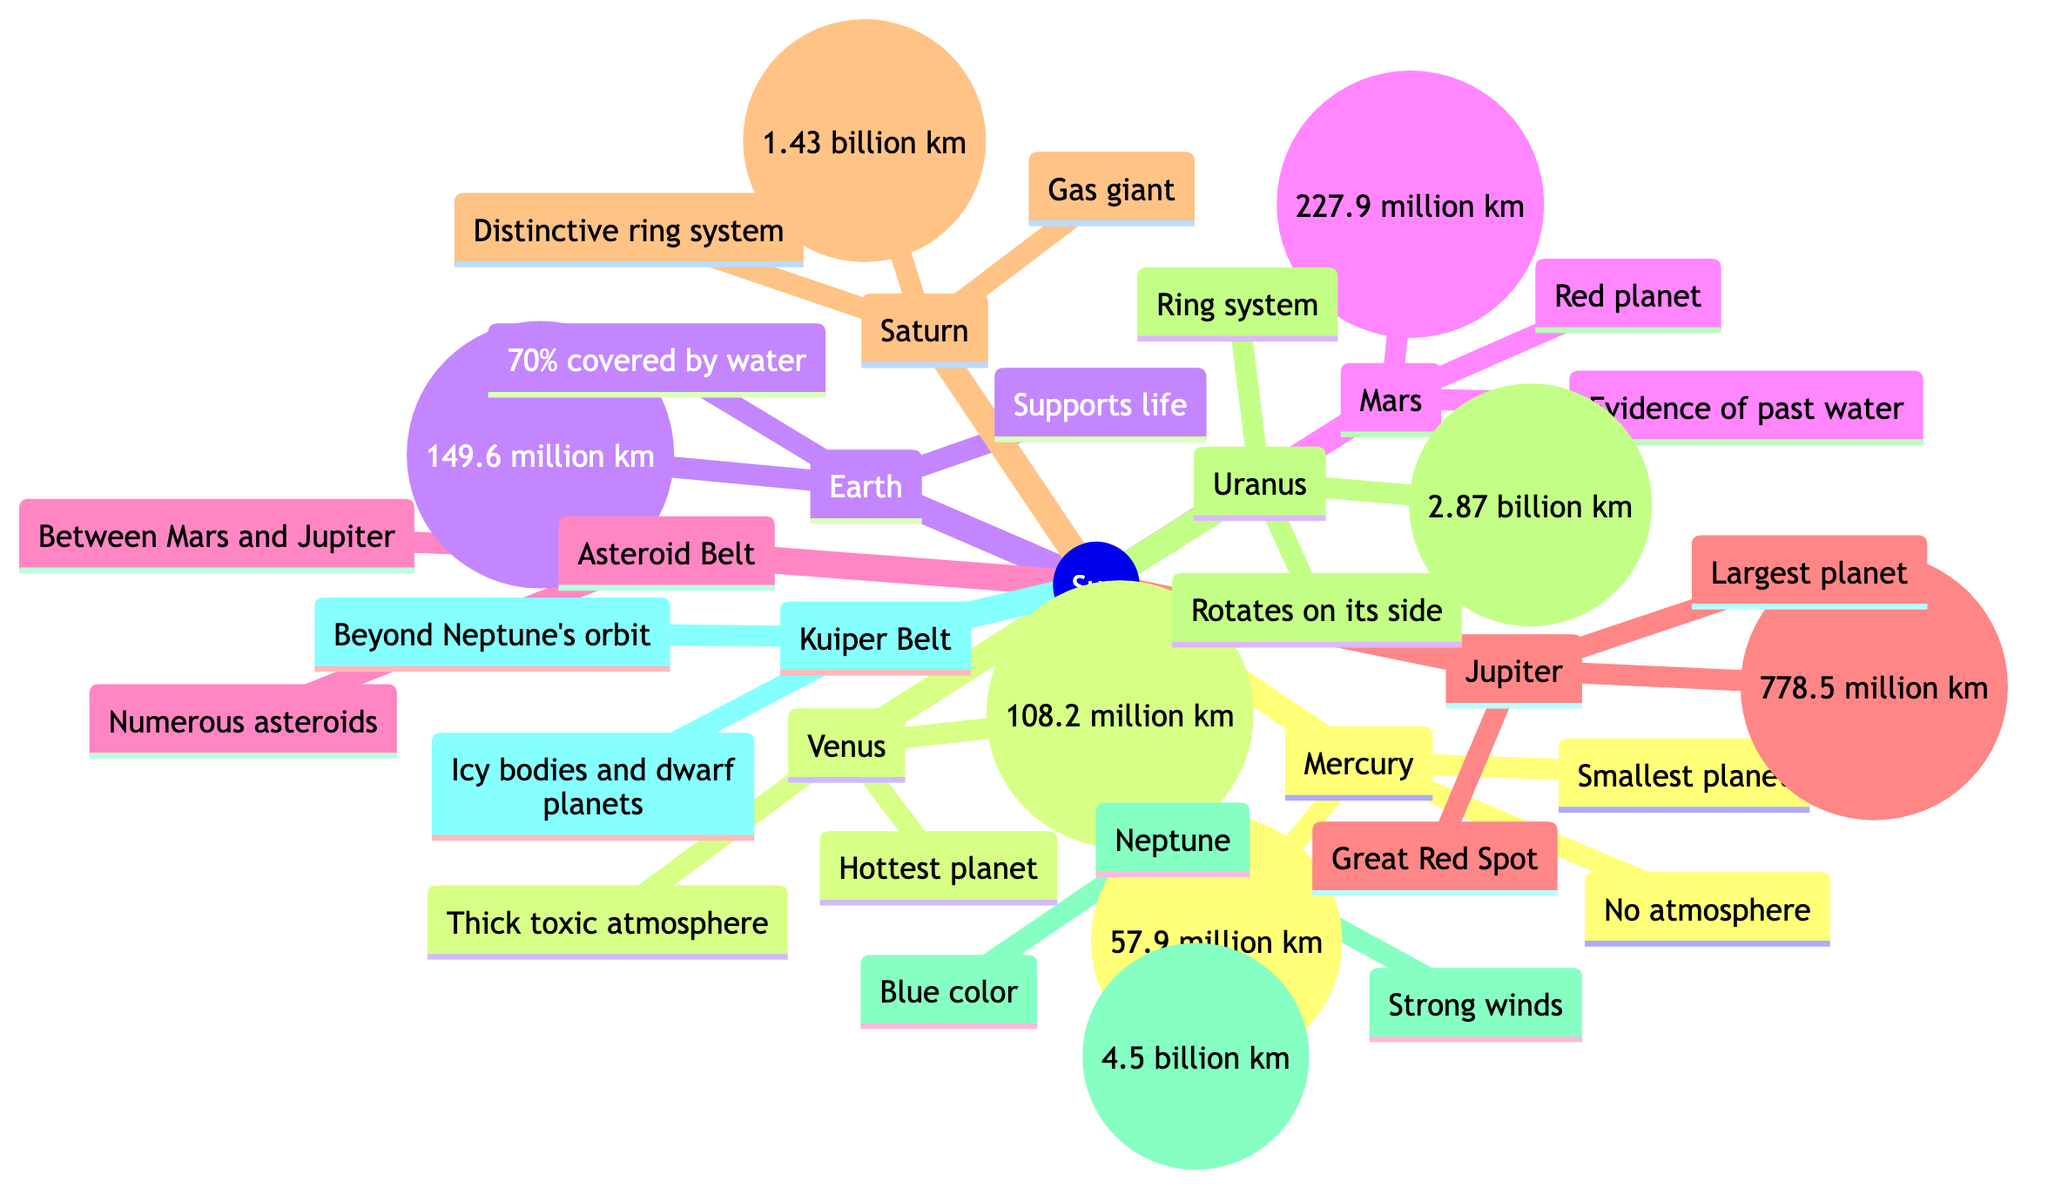What is the distance of Earth from the Sun? The diagram states that Earth's distance from the Sun is indicated as 149.6 million km. This information is directly labeled next to Earth in the diagram.
Answer: 149.6 million km Which planet is known as the "Red planet"? The diagram labels Mars as the "Red planet." This label is explicitly mentioned under the Mars node in the diagram.
Answer: Mars What is the total number of planets in the solar system as shown in the diagram? By counting the distinct planetary nodes in the diagram, we find Mercury, Venus, Earth, Mars, Jupiter, Saturn, Uranus, and Neptune, making a total of 8 planets.
Answer: 8 Which planet has the thickest atmosphere? Venus is labeled in the diagram as having a "Thick toxic atmosphere," making it identifiable as the planet with the thickest atmosphere.
Answer: Venus What feature is located between Mars and Jupiter? The diagram clearly identifies the "Asteroid Belt" as being situated between Mars and Jupiter, which is labeled directly in that section.
Answer: Asteroid Belt What type of celestial bodies are found in the Kuiper Belt? The diagram describes the Kuiper Belt as containing "Icy bodies and dwarf planets," thus directly providing information regarding the nature of these celestial bodies.
Answer: Icy bodies and dwarf planets How does Uranus rotate compared to other planets? According to the diagram, Uranus is noted to "Rotate on its side," which indicates a unique rotational characteristic compared to the other planets illustrated.
Answer: On its side What is the primary characteristic of Jupiter noted in the diagram? The diagram marks Jupiter as the "Largest planet" with a notable feature labeled as the "Great Red Spot," so its primary characteristic is its size.
Answer: Largest planet 